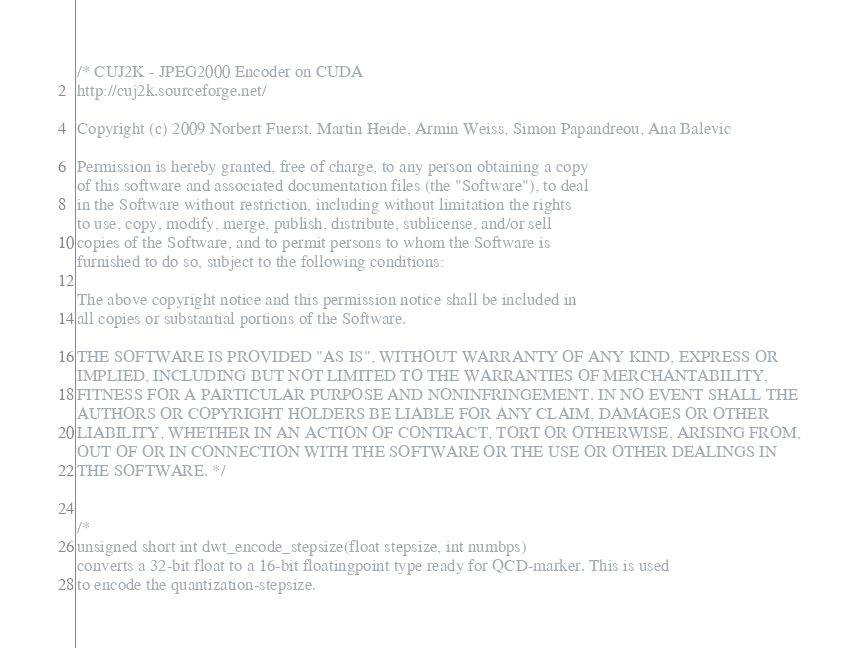Convert code to text. <code><loc_0><loc_0><loc_500><loc_500><_Cuda_>/* CUJ2K - JPEG2000 Encoder on CUDA
http://cuj2k.sourceforge.net/

Copyright (c) 2009 Norbert Fuerst, Martin Heide, Armin Weiss, Simon Papandreou, Ana Balevic

Permission is hereby granted, free of charge, to any person obtaining a copy
of this software and associated documentation files (the "Software"), to deal
in the Software without restriction, including without limitation the rights
to use, copy, modify, merge, publish, distribute, sublicense, and/or sell
copies of the Software, and to permit persons to whom the Software is
furnished to do so, subject to the following conditions:

The above copyright notice and this permission notice shall be included in
all copies or substantial portions of the Software.

THE SOFTWARE IS PROVIDED "AS IS", WITHOUT WARRANTY OF ANY KIND, EXPRESS OR
IMPLIED, INCLUDING BUT NOT LIMITED TO THE WARRANTIES OF MERCHANTABILITY,
FITNESS FOR A PARTICULAR PURPOSE AND NONINFRINGEMENT. IN NO EVENT SHALL THE
AUTHORS OR COPYRIGHT HOLDERS BE LIABLE FOR ANY CLAIM, DAMAGES OR OTHER
LIABILITY, WHETHER IN AN ACTION OF CONTRACT, TORT OR OTHERWISE, ARISING FROM,
OUT OF OR IN CONNECTION WITH THE SOFTWARE OR THE USE OR OTHER DEALINGS IN
THE SOFTWARE. */


/*
unsigned short int dwt_encode_stepsize(float stepsize, int numbps)
converts a 32-bit float to a 16-bit floatingpoint type ready for QCD-marker. This is used
to encode the quantization-stepsize.
</code> 